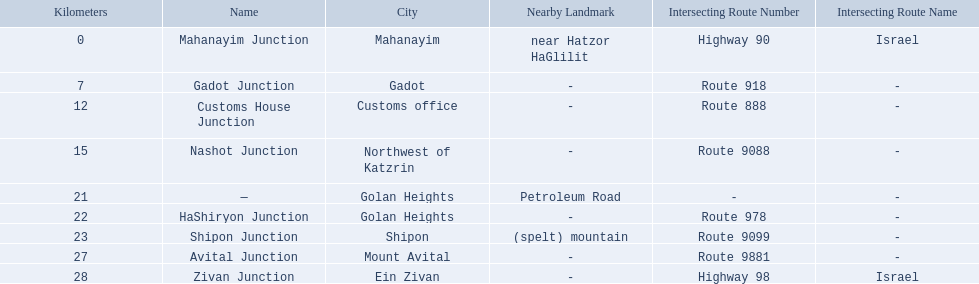Which junctions cross a route? Gadot Junction, Customs House Junction, Nashot Junction, HaShiryon Junction, Shipon Junction, Avital Junction. Which of these shares [art of its name with its locations name? Gadot Junction, Customs House Junction, Shipon Junction, Avital Junction. Which of them is not located in a locations named after a mountain? Gadot Junction, Customs House Junction. Which of these has the highest route number? Gadot Junction. 